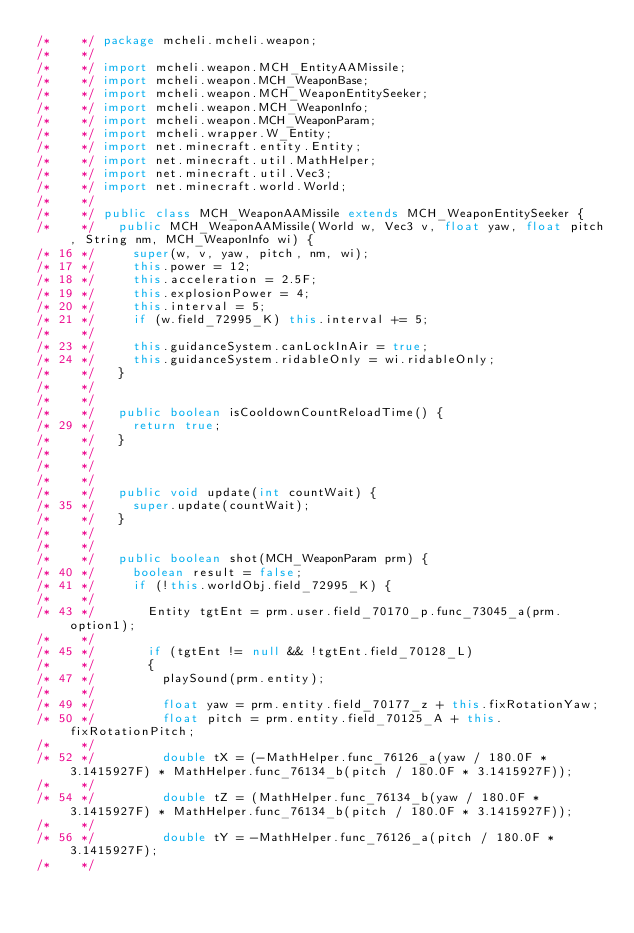<code> <loc_0><loc_0><loc_500><loc_500><_Java_>/*    */ package mcheli.mcheli.weapon;
/*    */ 
/*    */ import mcheli.weapon.MCH_EntityAAMissile;
/*    */ import mcheli.weapon.MCH_WeaponBase;
/*    */ import mcheli.weapon.MCH_WeaponEntitySeeker;
/*    */ import mcheli.weapon.MCH_WeaponInfo;
/*    */ import mcheli.weapon.MCH_WeaponParam;
/*    */ import mcheli.wrapper.W_Entity;
/*    */ import net.minecraft.entity.Entity;
/*    */ import net.minecraft.util.MathHelper;
/*    */ import net.minecraft.util.Vec3;
/*    */ import net.minecraft.world.World;
/*    */ 
/*    */ public class MCH_WeaponAAMissile extends MCH_WeaponEntitySeeker {
/*    */   public MCH_WeaponAAMissile(World w, Vec3 v, float yaw, float pitch, String nm, MCH_WeaponInfo wi) {
/* 16 */     super(w, v, yaw, pitch, nm, wi);
/* 17 */     this.power = 12;
/* 18 */     this.acceleration = 2.5F;
/* 19 */     this.explosionPower = 4;
/* 20 */     this.interval = 5;
/* 21 */     if (w.field_72995_K) this.interval += 5;
/*    */     
/* 23 */     this.guidanceSystem.canLockInAir = true;
/* 24 */     this.guidanceSystem.ridableOnly = wi.ridableOnly;
/*    */   }
/*    */ 
/*    */   
/*    */   public boolean isCooldownCountReloadTime() {
/* 29 */     return true;
/*    */   }
/*    */ 
/*    */ 
/*    */   
/*    */   public void update(int countWait) {
/* 35 */     super.update(countWait);
/*    */   }
/*    */ 
/*    */   
/*    */   public boolean shot(MCH_WeaponParam prm) {
/* 40 */     boolean result = false;
/* 41 */     if (!this.worldObj.field_72995_K) {
/*    */       
/* 43 */       Entity tgtEnt = prm.user.field_70170_p.func_73045_a(prm.option1);
/*    */       
/* 45 */       if (tgtEnt != null && !tgtEnt.field_70128_L)
/*    */       {
/* 47 */         playSound(prm.entity);
/*    */         
/* 49 */         float yaw = prm.entity.field_70177_z + this.fixRotationYaw;
/* 50 */         float pitch = prm.entity.field_70125_A + this.fixRotationPitch;
/*    */         
/* 52 */         double tX = (-MathHelper.func_76126_a(yaw / 180.0F * 3.1415927F) * MathHelper.func_76134_b(pitch / 180.0F * 3.1415927F));
/*    */         
/* 54 */         double tZ = (MathHelper.func_76134_b(yaw / 180.0F * 3.1415927F) * MathHelper.func_76134_b(pitch / 180.0F * 3.1415927F));
/*    */         
/* 56 */         double tY = -MathHelper.func_76126_a(pitch / 180.0F * 3.1415927F);
/*    */         </code> 